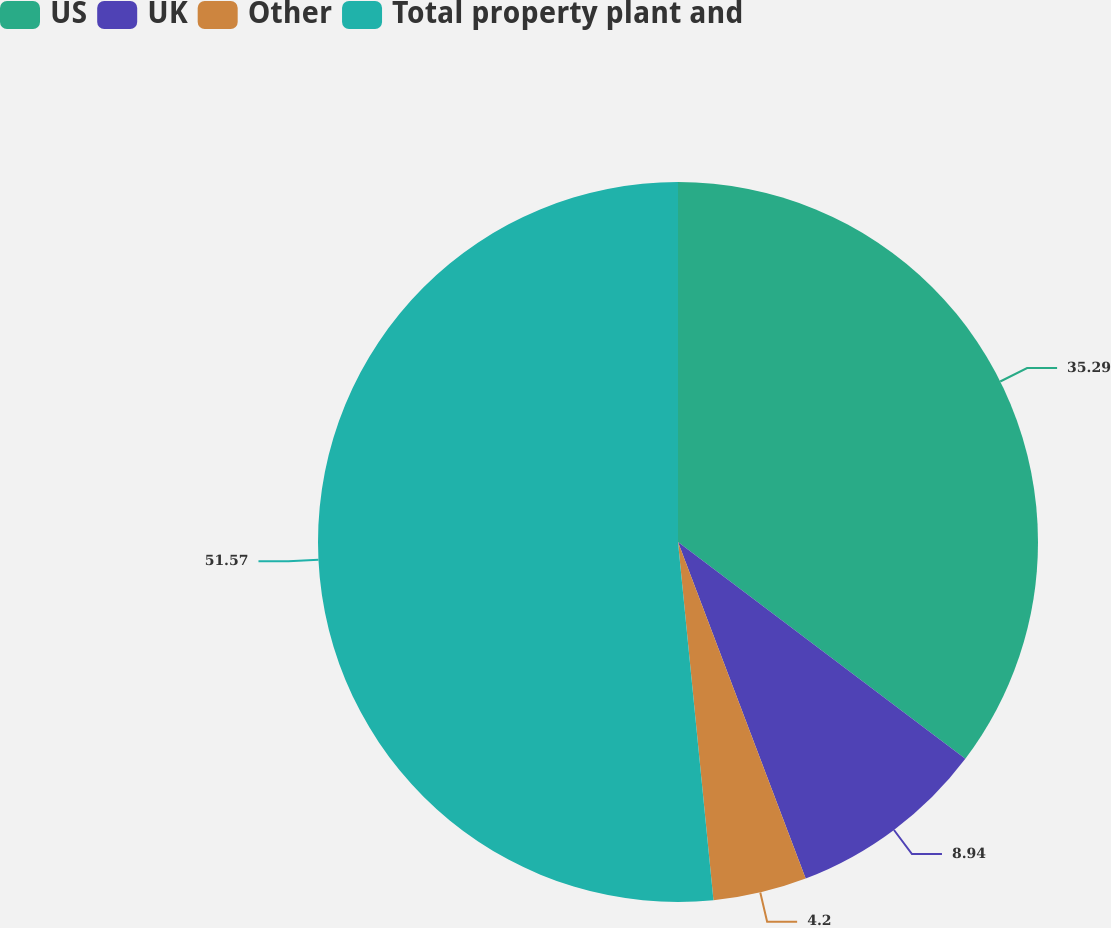Convert chart. <chart><loc_0><loc_0><loc_500><loc_500><pie_chart><fcel>US<fcel>UK<fcel>Other<fcel>Total property plant and<nl><fcel>35.29%<fcel>8.94%<fcel>4.2%<fcel>51.57%<nl></chart> 